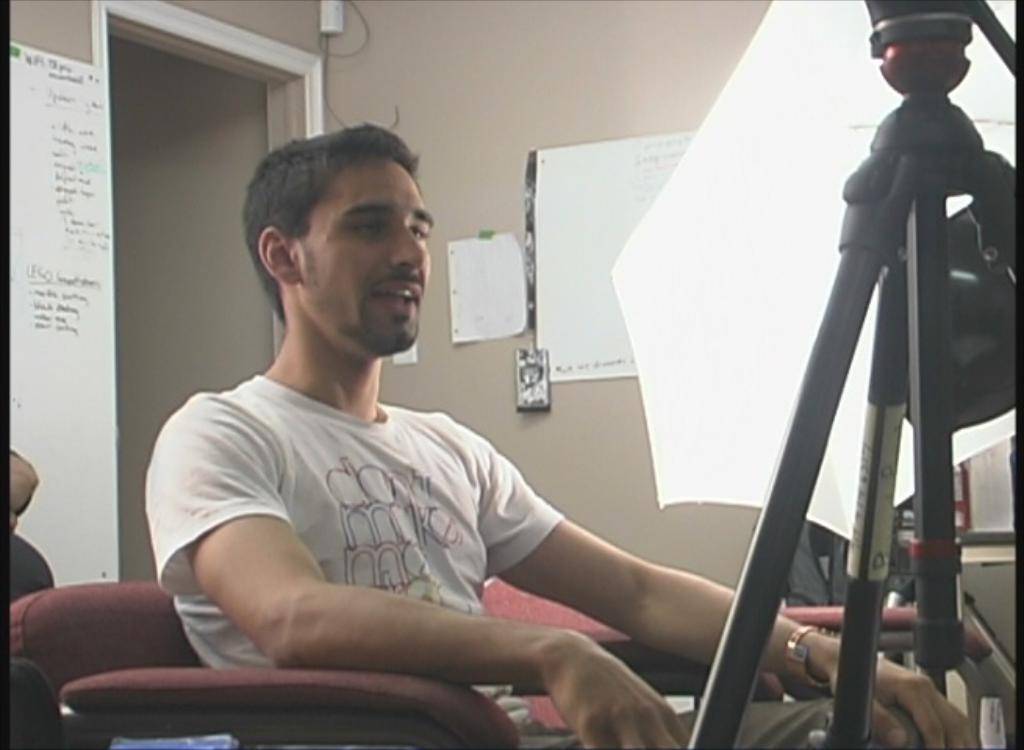What is the man in the image doing? The man is sitting in a sofa. What object is in front of the man? There is a tripod stand in front of the man. What can be seen on the wall in the background? There are charts pasted on a wall in the background. What type of butter is the man using to grease the monkey's paws in the image? There is no butter or monkey present in the image; the man is sitting in a sofa with a tripod stand in front of him and charts on the wall in the background. 